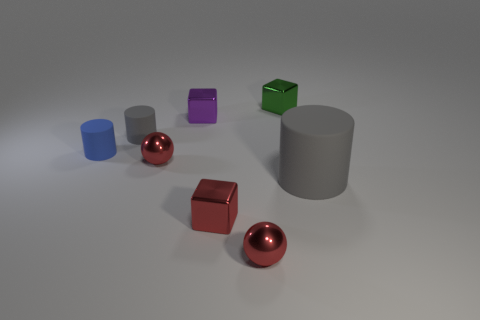Subtract all small blue cylinders. How many cylinders are left? 2 Subtract all cyan spheres. How many gray cylinders are left? 2 Add 1 small red metal objects. How many objects exist? 9 Subtract all red cubes. How many cubes are left? 2 Subtract 1 cubes. How many cubes are left? 2 Subtract all cylinders. How many objects are left? 5 Subtract all red cylinders. Subtract all blue cubes. How many cylinders are left? 3 Subtract 0 purple spheres. How many objects are left? 8 Subtract all cubes. Subtract all large gray rubber cylinders. How many objects are left? 4 Add 5 green metallic things. How many green metallic things are left? 6 